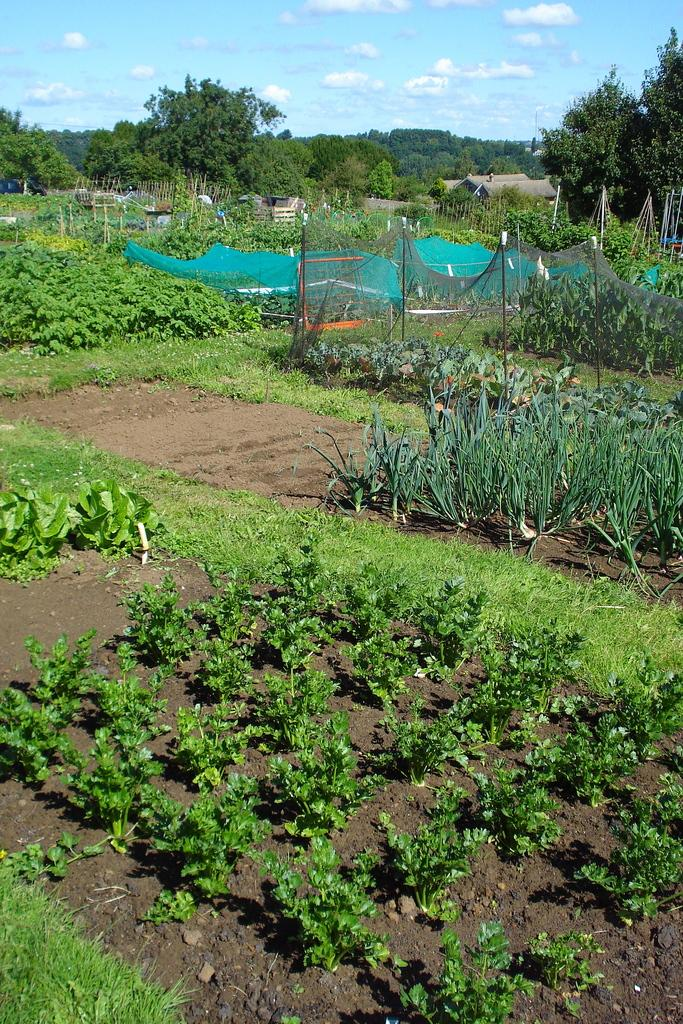What type of vegetation is present on the ground in the image? There are plants on the ground in the image. What structure can be seen in the image? There is a fencing net in the image. What material is present in the image? There is a cloth in the image. What type of support structures are visible in the image? There are poles in the image. What type of buildings can be seen in the image? There are houses in the image. What other natural elements are present in the image? There are trees in the image. What else can be seen in the image? There are some objects in the image. What is visible in the background of the image? The sky with clouds is visible in the background of the image. How many clams are sitting on the stove in the image? There are no clams or stoves present in the image. What type of net is used to catch the net in the image? There is no net-catching activity depicted in the image; the fencing net is not used for catching nets. 